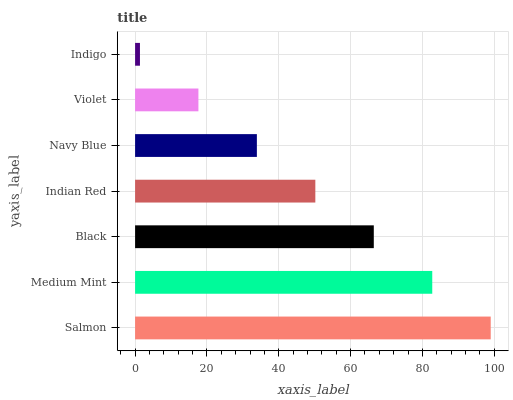Is Indigo the minimum?
Answer yes or no. Yes. Is Salmon the maximum?
Answer yes or no. Yes. Is Medium Mint the minimum?
Answer yes or no. No. Is Medium Mint the maximum?
Answer yes or no. No. Is Salmon greater than Medium Mint?
Answer yes or no. Yes. Is Medium Mint less than Salmon?
Answer yes or no. Yes. Is Medium Mint greater than Salmon?
Answer yes or no. No. Is Salmon less than Medium Mint?
Answer yes or no. No. Is Indian Red the high median?
Answer yes or no. Yes. Is Indian Red the low median?
Answer yes or no. Yes. Is Medium Mint the high median?
Answer yes or no. No. Is Indigo the low median?
Answer yes or no. No. 